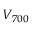<formula> <loc_0><loc_0><loc_500><loc_500>V _ { 7 0 0 }</formula> 